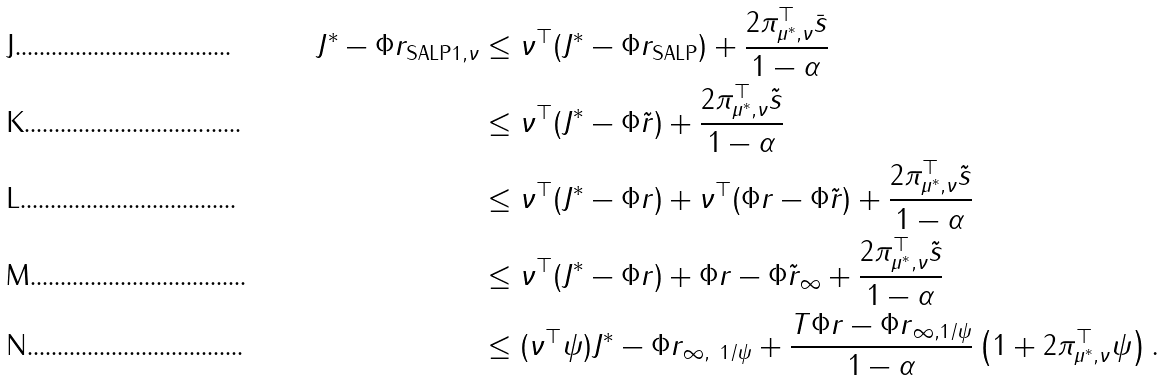<formula> <loc_0><loc_0><loc_500><loc_500>\| J ^ { * } - \Phi r _ { \text {SALP} } \| _ { 1 , \nu } & \leq \nu ^ { \top } ( J ^ { * } - \Phi r _ { \text {SALP} } ) + \frac { 2 \pi ^ { \top } _ { \mu ^ { * } , \nu } \bar { s } } { 1 - \alpha } \\ & \leq \nu ^ { \top } ( J ^ { * } - \Phi \tilde { r } ) + \frac { 2 \pi ^ { \top } _ { \mu ^ { * } , \nu } \tilde { s } } { 1 - \alpha } \\ & \leq \nu ^ { \top } ( J ^ { * } - \Phi r ) + \nu ^ { \top } ( \Phi r - \Phi \tilde { r } ) + \frac { 2 \pi ^ { \top } _ { \mu ^ { * } , \nu } \tilde { s } } { 1 - \alpha } \\ & \leq \nu ^ { \top } ( J ^ { * } - \Phi r ) + \| \Phi r - \Phi \tilde { r } \| _ { \infty } + \frac { 2 \pi ^ { \top } _ { \mu ^ { * } , \nu } \tilde { s } } { 1 - \alpha } \\ & \leq ( \nu ^ { \top } \psi ) \| J ^ { * } - \Phi r \| _ { \infty , \ 1 / \psi } + \frac { \| T \Phi r - \Phi r \| _ { \infty , 1 / \psi } } { 1 - \alpha } \left ( 1 + 2 \pi _ { \mu ^ { * } , \nu } ^ { \top } \psi \right ) .</formula> 